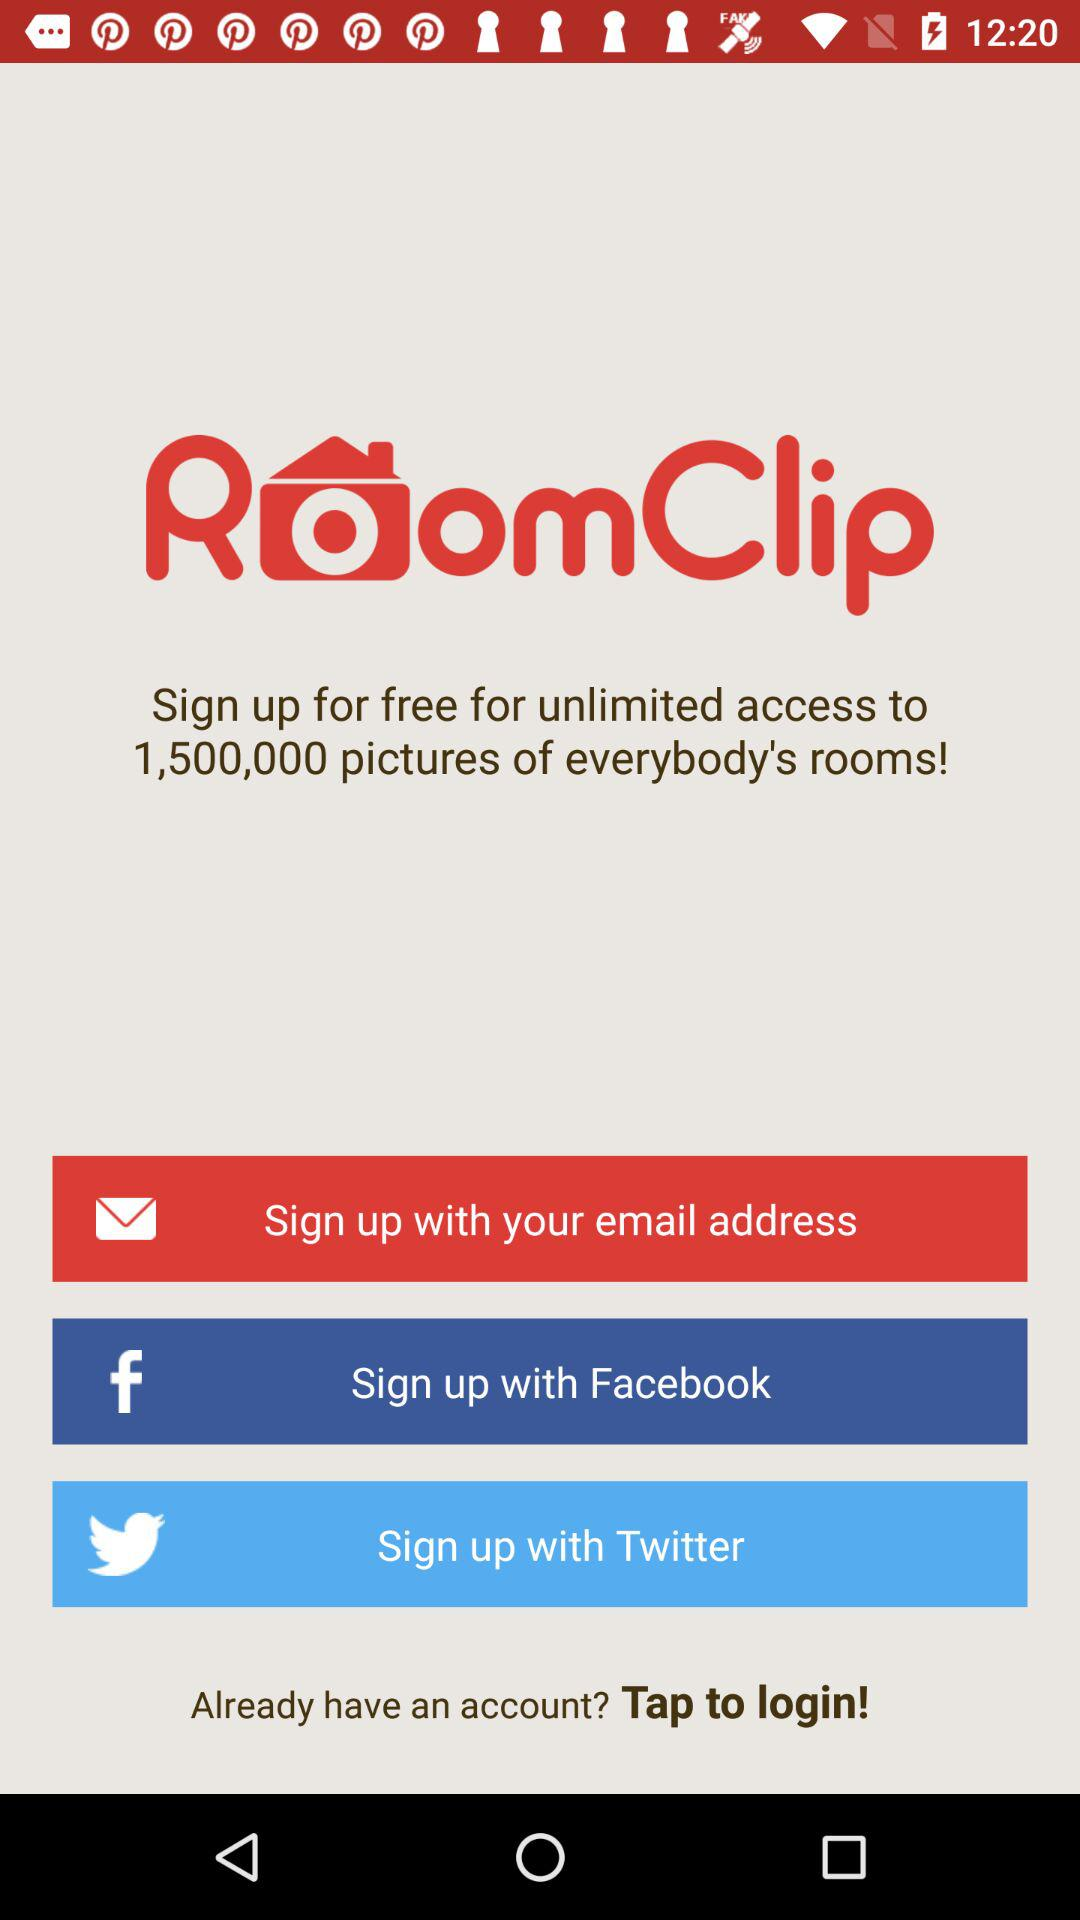What accounts can I use to sign up? You can sign up with "email address", "Facebook" and "Twitter". 